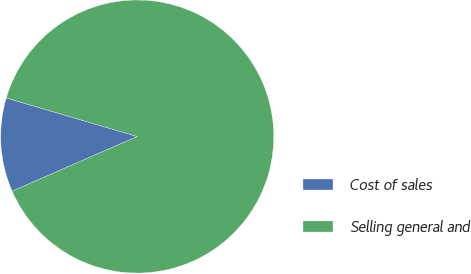<chart> <loc_0><loc_0><loc_500><loc_500><pie_chart><fcel>Cost of sales<fcel>Selling general and<nl><fcel>11.11%<fcel>88.89%<nl></chart> 